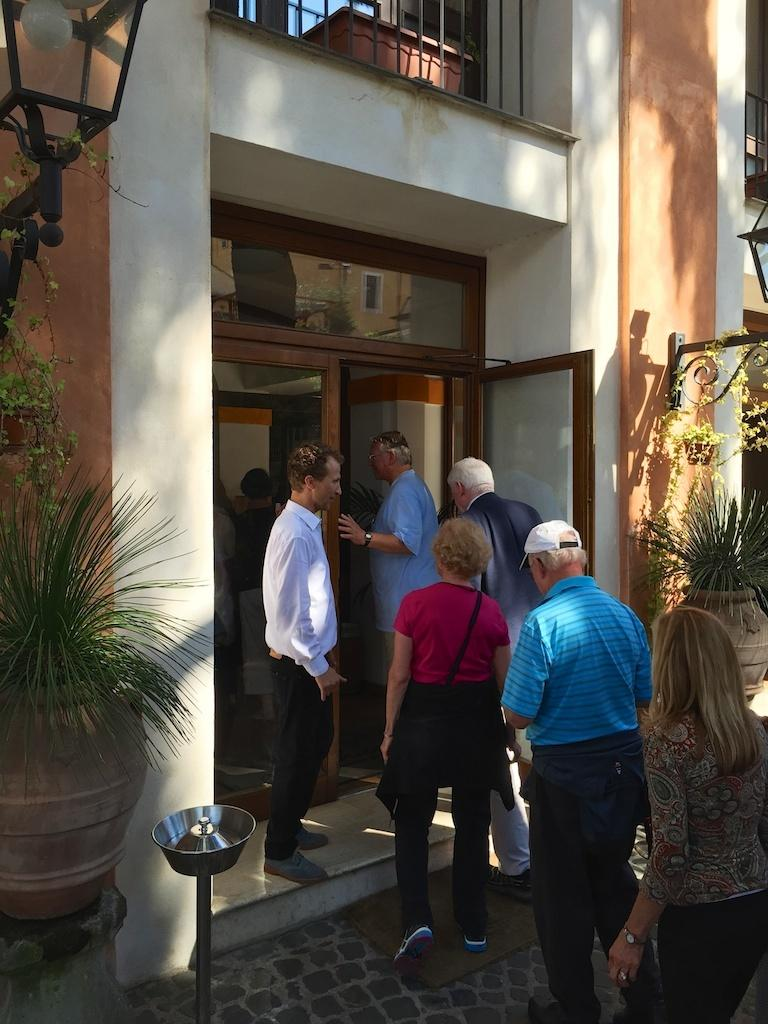How many people are in the image? There is a group of people standing in the image, but the exact number cannot be determined from the provided facts. What else can be seen in the image besides the people? There are plants, lights, iron grills, a mat, buildings, and a door in the image. What type of plants are visible in the image? The provided facts do not specify the type of plants in the image. What is the purpose of the lights in the image? The purpose of the lights in the image cannot be determined from the provided facts. What type of celery is being used as a whistle by the people in the image? There is no celery or whistle present in the image. What type of work are the people in the image engaged in? The provided facts do not indicate what type of work the people in the image might be doing. 